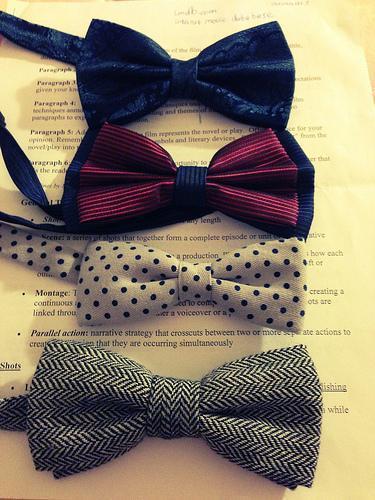How many bowties have polka dots?
Give a very brief answer. 1. How many bow ties are in the image?
Give a very brief answer. 4. 